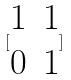<formula> <loc_0><loc_0><loc_500><loc_500>[ \begin{matrix} 1 & 1 \\ 0 & 1 \end{matrix} ]</formula> 